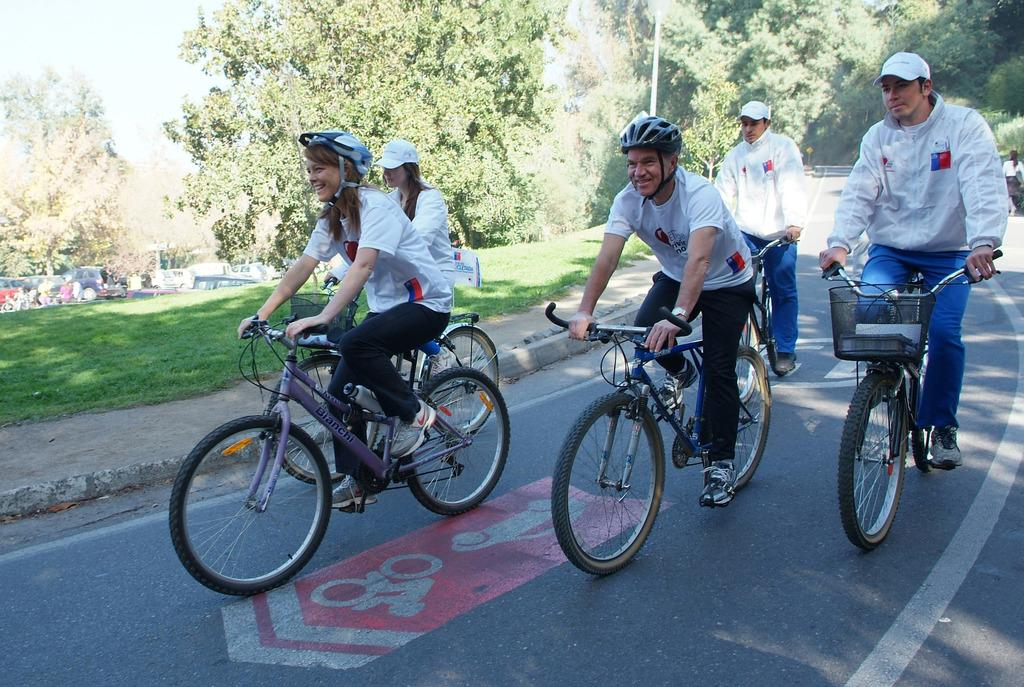How many people are in the image? There is a group of persons in the image. What are the persons doing in the image? The persons are riding bicycles. Where are the bicycles located? The bicycles are on a road. What can be seen in the background of the image? There are trees in the background of the image. What type of parenting advice can be seen in the image? There is no parenting advice present in the image; it features a group of persons riding bicycles on a road with trees in the background. 